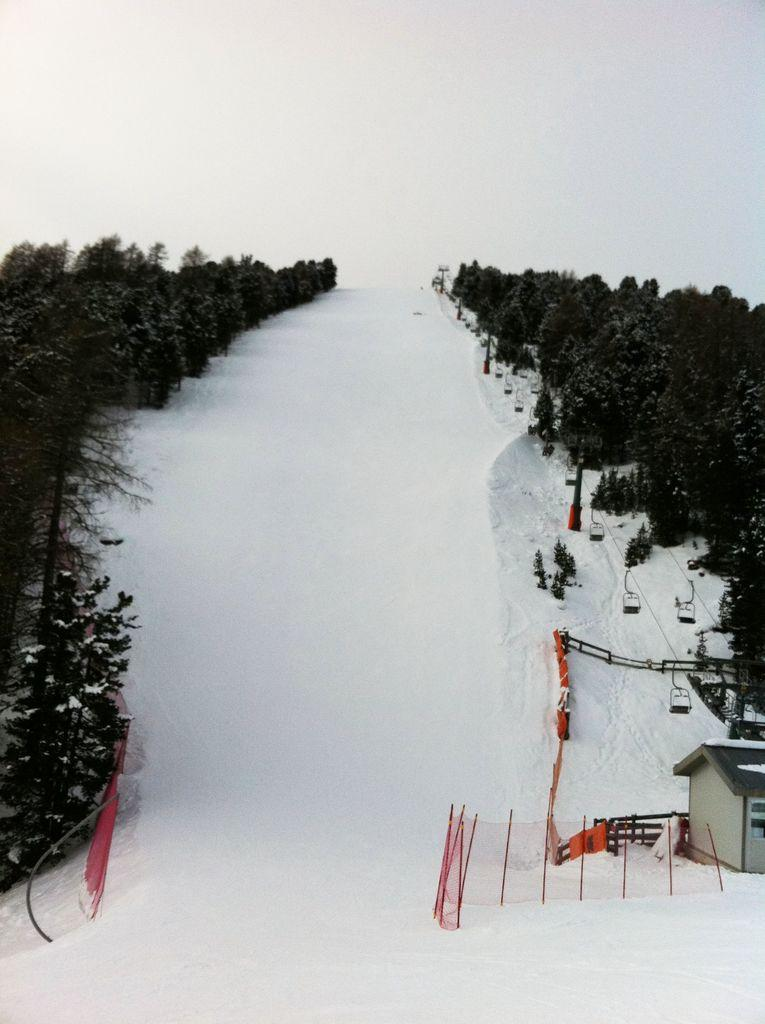What is covering the land in the image? There is snow on the land in the image. What color is the fence in the image? The fence in the image is red. What type of building can be seen on the right side of the image? There is a cabin on the right side of the image. What type of vegetation is present in the image? Trees are present in the image. What color dominates the background of the image? The background of the image is white. Can you tell me how many fans are visible in the image? There are no fans present in the image. What type of force is being exerted on the cabin in the image? There is no force being exerted on the cabin in the image; it is stationary. 